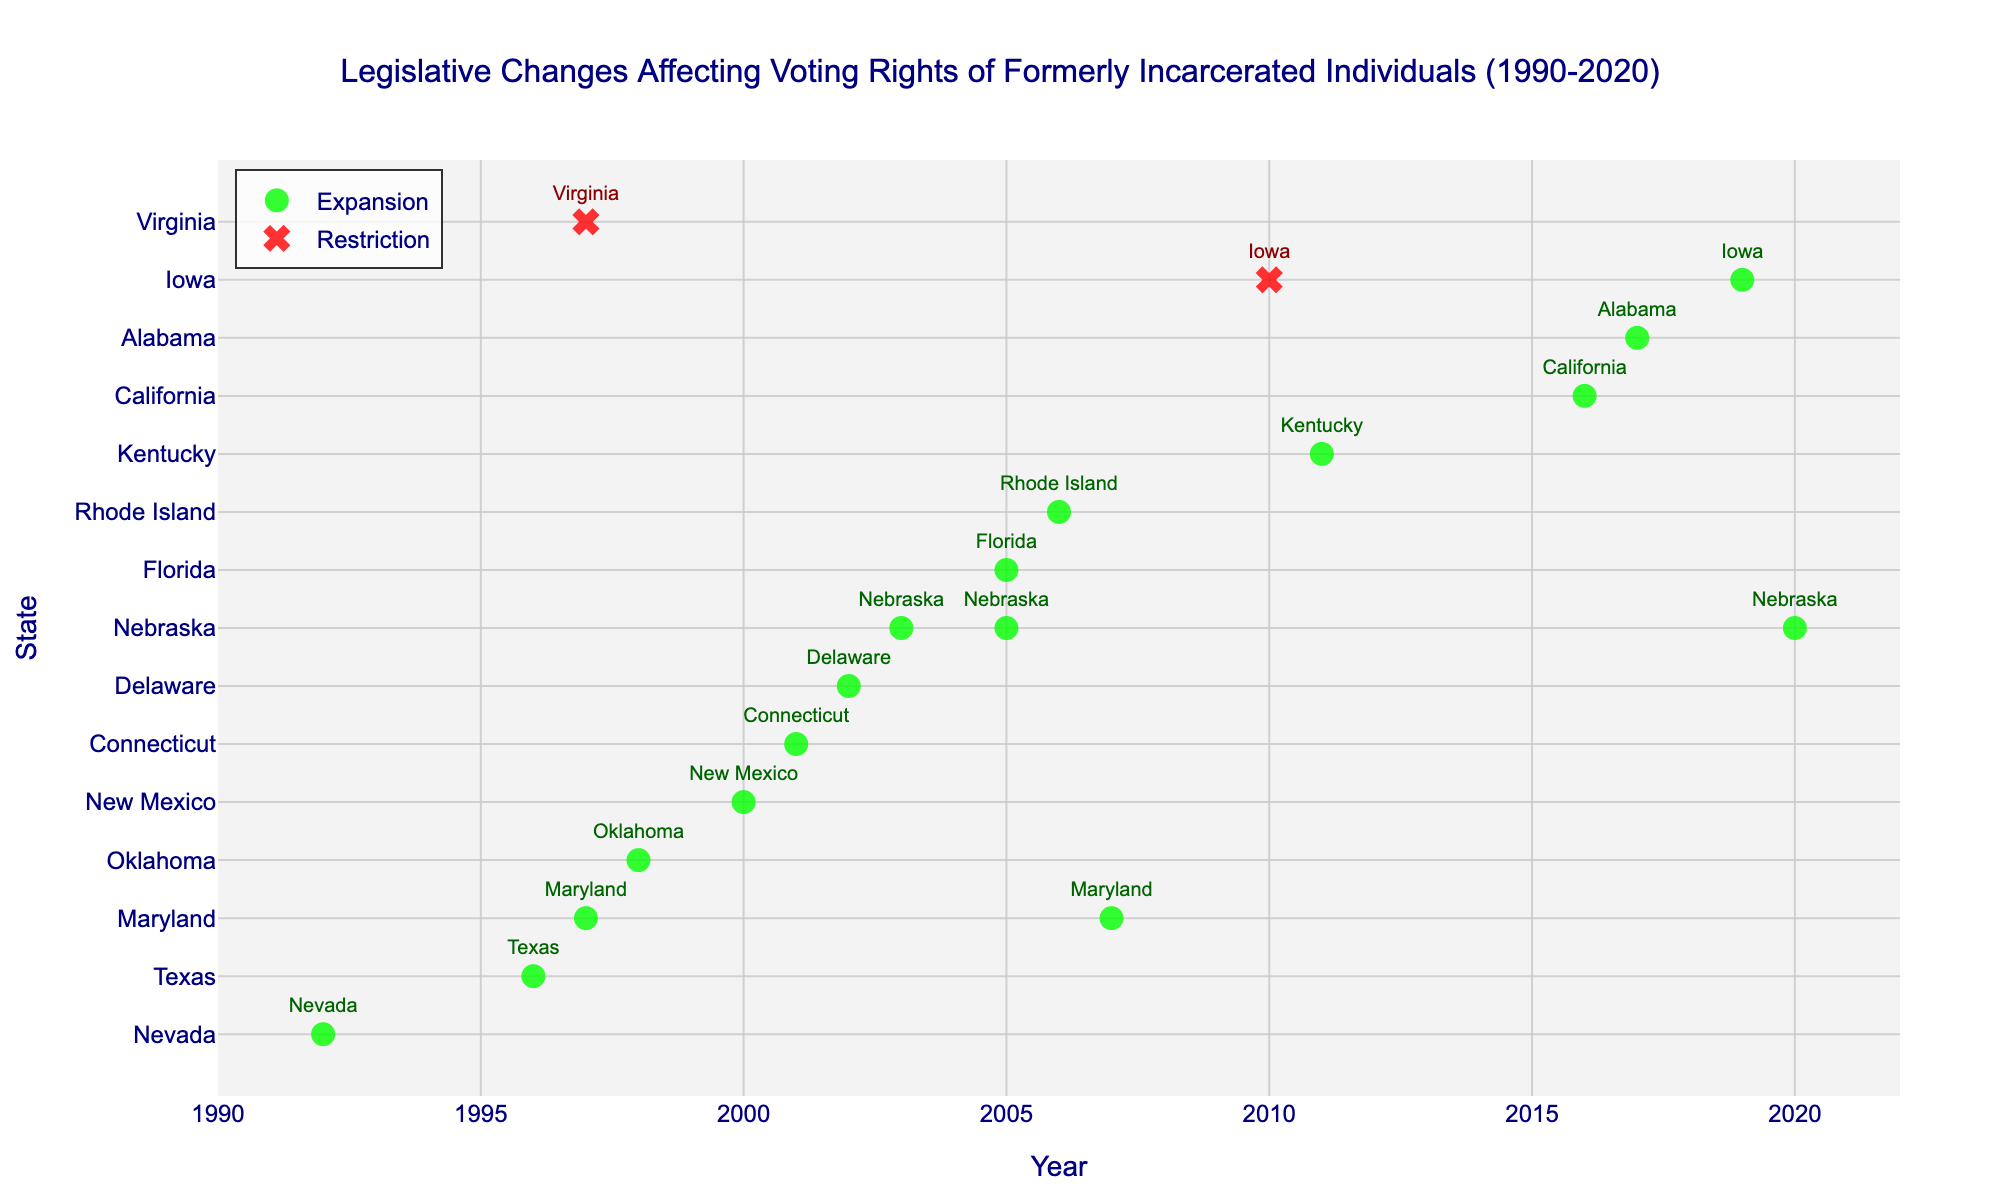what is the title of the figure? The title can be found at the top center of the figure, indicating the purpose or content of the data visualization.
Answer: Legislative Changes Affecting Voting Rights of Formerly Incarcerated Individuals (1990-2020) Which years did Nebraska make changes to voting rights? The years Nebraska made changes are marked on the x-axis, with state labels on the y-axis corresponding to the markers for Nebraska.
Answer: 2003, 2005, 2020 How many states expanded voting rights in 2005? Look for the "Expansion" markers on the x-axis at 2005 and count the states listed as text labels on the y-axis.
Answer: 2 Which state had a restriction change in voting rights in 2010? Find the red "x" marker on the x-axis at 2010, and note the state label on the y-axis.
Answer: Iowa What is the range of years covered in this figure? The range can be determined by examining the farthest left and right points on the x-axis, indicating the start and end years.
Answer: 1990 to 2020 Between Maryland and Nebraska, which state made changes more frequently? Count the number of markers on the y-axis for Maryland and Nebraska, representing each legislative change they made.
Answer: Nebraska During which period were the most legislative expansions enacted, 1990-2005 or 2006-2020? Count the number of green circle markers representing expansions in both periods, then compare the counts.
Answer: 2006-2020 Which state had the first recorded expansion in the data set? Find the earliest green circle marker on the x-axis and identify the state noted in the corresponding y-axis label.
Answer: Nevada What is the longest gap, in years, between recorded legislative changes? Calculate the differences in years between consecutive markers along the x-axis and determine the maximum gap.
Answer: 1992 to 1996 (4 years) How many legislative changes occurred in 2017? Count the number of markers (both expansions and restrictions) present on the x-axis at the year 2017.
Answer: 1 